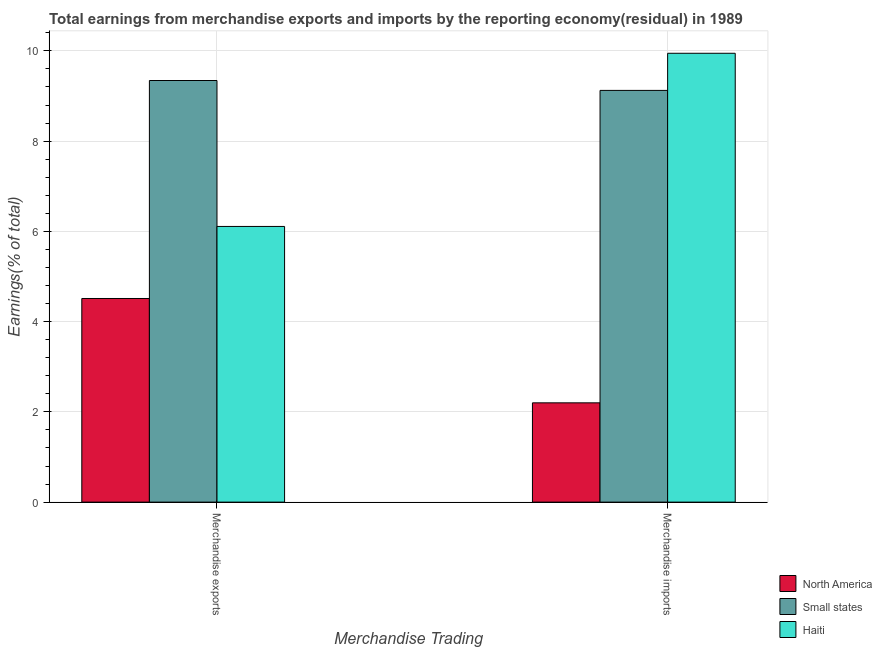How many groups of bars are there?
Your answer should be compact. 2. Are the number of bars per tick equal to the number of legend labels?
Give a very brief answer. Yes. Are the number of bars on each tick of the X-axis equal?
Offer a very short reply. Yes. How many bars are there on the 1st tick from the left?
Your answer should be compact. 3. What is the earnings from merchandise exports in North America?
Ensure brevity in your answer.  4.51. Across all countries, what is the maximum earnings from merchandise imports?
Offer a terse response. 9.95. Across all countries, what is the minimum earnings from merchandise exports?
Provide a succinct answer. 4.51. In which country was the earnings from merchandise exports maximum?
Offer a terse response. Small states. In which country was the earnings from merchandise exports minimum?
Make the answer very short. North America. What is the total earnings from merchandise imports in the graph?
Your answer should be compact. 21.27. What is the difference between the earnings from merchandise exports in North America and that in Small states?
Make the answer very short. -4.83. What is the difference between the earnings from merchandise exports in Small states and the earnings from merchandise imports in North America?
Make the answer very short. 7.14. What is the average earnings from merchandise imports per country?
Provide a succinct answer. 7.09. What is the difference between the earnings from merchandise imports and earnings from merchandise exports in Small states?
Offer a terse response. -0.22. What is the ratio of the earnings from merchandise imports in Haiti to that in North America?
Give a very brief answer. 4.52. What does the 1st bar from the right in Merchandise exports represents?
Keep it short and to the point. Haiti. How many bars are there?
Make the answer very short. 6. How many countries are there in the graph?
Your answer should be compact. 3. Are the values on the major ticks of Y-axis written in scientific E-notation?
Offer a very short reply. No. Does the graph contain any zero values?
Ensure brevity in your answer.  No. Does the graph contain grids?
Your answer should be compact. Yes. Where does the legend appear in the graph?
Give a very brief answer. Bottom right. How many legend labels are there?
Offer a very short reply. 3. How are the legend labels stacked?
Offer a very short reply. Vertical. What is the title of the graph?
Give a very brief answer. Total earnings from merchandise exports and imports by the reporting economy(residual) in 1989. Does "Uganda" appear as one of the legend labels in the graph?
Your answer should be very brief. No. What is the label or title of the X-axis?
Your answer should be very brief. Merchandise Trading. What is the label or title of the Y-axis?
Give a very brief answer. Earnings(% of total). What is the Earnings(% of total) in North America in Merchandise exports?
Offer a terse response. 4.51. What is the Earnings(% of total) in Small states in Merchandise exports?
Provide a succinct answer. 9.34. What is the Earnings(% of total) in Haiti in Merchandise exports?
Give a very brief answer. 6.11. What is the Earnings(% of total) of North America in Merchandise imports?
Provide a short and direct response. 2.2. What is the Earnings(% of total) of Small states in Merchandise imports?
Keep it short and to the point. 9.12. What is the Earnings(% of total) of Haiti in Merchandise imports?
Your response must be concise. 9.95. Across all Merchandise Trading, what is the maximum Earnings(% of total) of North America?
Offer a very short reply. 4.51. Across all Merchandise Trading, what is the maximum Earnings(% of total) of Small states?
Your response must be concise. 9.34. Across all Merchandise Trading, what is the maximum Earnings(% of total) of Haiti?
Your answer should be compact. 9.95. Across all Merchandise Trading, what is the minimum Earnings(% of total) of North America?
Your answer should be very brief. 2.2. Across all Merchandise Trading, what is the minimum Earnings(% of total) in Small states?
Offer a terse response. 9.12. Across all Merchandise Trading, what is the minimum Earnings(% of total) in Haiti?
Your response must be concise. 6.11. What is the total Earnings(% of total) of North America in the graph?
Offer a terse response. 6.71. What is the total Earnings(% of total) in Small states in the graph?
Ensure brevity in your answer.  18.47. What is the total Earnings(% of total) in Haiti in the graph?
Provide a succinct answer. 16.06. What is the difference between the Earnings(% of total) in North America in Merchandise exports and that in Merchandise imports?
Your answer should be compact. 2.31. What is the difference between the Earnings(% of total) of Small states in Merchandise exports and that in Merchandise imports?
Ensure brevity in your answer.  0.22. What is the difference between the Earnings(% of total) of Haiti in Merchandise exports and that in Merchandise imports?
Your response must be concise. -3.84. What is the difference between the Earnings(% of total) of North America in Merchandise exports and the Earnings(% of total) of Small states in Merchandise imports?
Your response must be concise. -4.61. What is the difference between the Earnings(% of total) of North America in Merchandise exports and the Earnings(% of total) of Haiti in Merchandise imports?
Your answer should be compact. -5.43. What is the difference between the Earnings(% of total) in Small states in Merchandise exports and the Earnings(% of total) in Haiti in Merchandise imports?
Provide a succinct answer. -0.6. What is the average Earnings(% of total) in North America per Merchandise Trading?
Provide a succinct answer. 3.36. What is the average Earnings(% of total) in Small states per Merchandise Trading?
Offer a terse response. 9.23. What is the average Earnings(% of total) in Haiti per Merchandise Trading?
Your response must be concise. 8.03. What is the difference between the Earnings(% of total) in North America and Earnings(% of total) in Small states in Merchandise exports?
Provide a short and direct response. -4.83. What is the difference between the Earnings(% of total) in North America and Earnings(% of total) in Haiti in Merchandise exports?
Your response must be concise. -1.6. What is the difference between the Earnings(% of total) in Small states and Earnings(% of total) in Haiti in Merchandise exports?
Your response must be concise. 3.23. What is the difference between the Earnings(% of total) of North America and Earnings(% of total) of Small states in Merchandise imports?
Your answer should be very brief. -6.92. What is the difference between the Earnings(% of total) in North America and Earnings(% of total) in Haiti in Merchandise imports?
Provide a succinct answer. -7.75. What is the difference between the Earnings(% of total) of Small states and Earnings(% of total) of Haiti in Merchandise imports?
Keep it short and to the point. -0.82. What is the ratio of the Earnings(% of total) in North America in Merchandise exports to that in Merchandise imports?
Make the answer very short. 2.05. What is the ratio of the Earnings(% of total) of Haiti in Merchandise exports to that in Merchandise imports?
Your answer should be compact. 0.61. What is the difference between the highest and the second highest Earnings(% of total) in North America?
Keep it short and to the point. 2.31. What is the difference between the highest and the second highest Earnings(% of total) in Small states?
Provide a succinct answer. 0.22. What is the difference between the highest and the second highest Earnings(% of total) of Haiti?
Your answer should be very brief. 3.84. What is the difference between the highest and the lowest Earnings(% of total) in North America?
Provide a short and direct response. 2.31. What is the difference between the highest and the lowest Earnings(% of total) in Small states?
Provide a short and direct response. 0.22. What is the difference between the highest and the lowest Earnings(% of total) of Haiti?
Offer a very short reply. 3.84. 